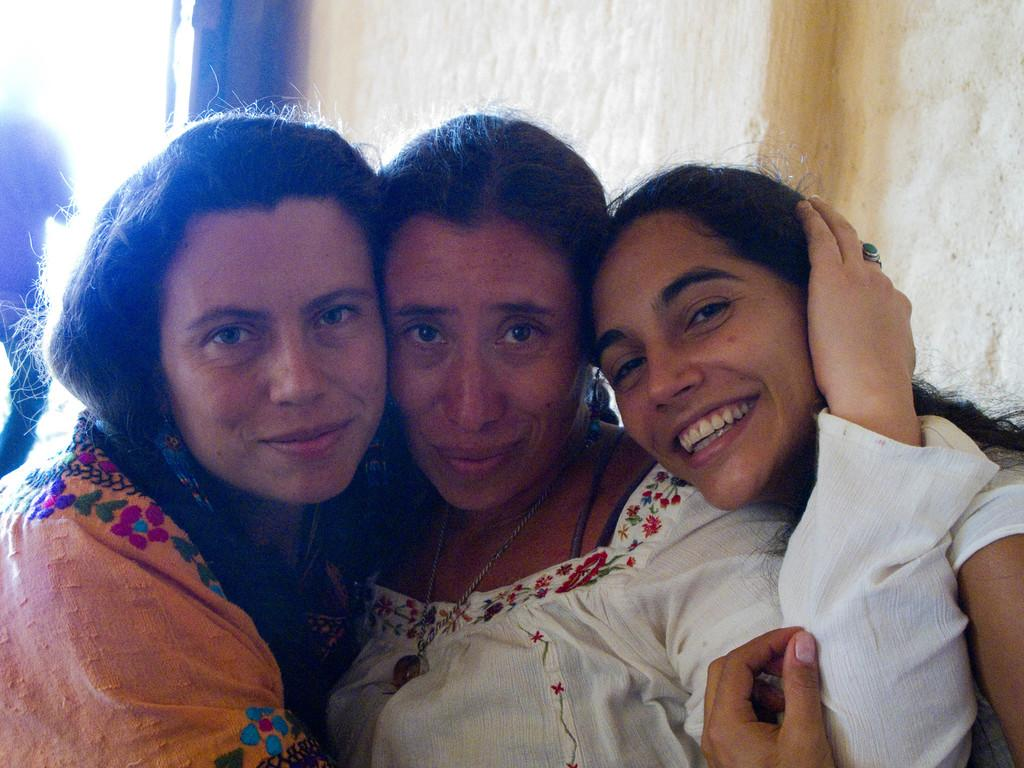How many people are present in the image? There are three women in the image. What can be seen in the background of the image? There is a wall in the background of the image. What type of mint is growing on the wall in the image? There is no mint present in the image; the wall is the only feature visible in the background. 